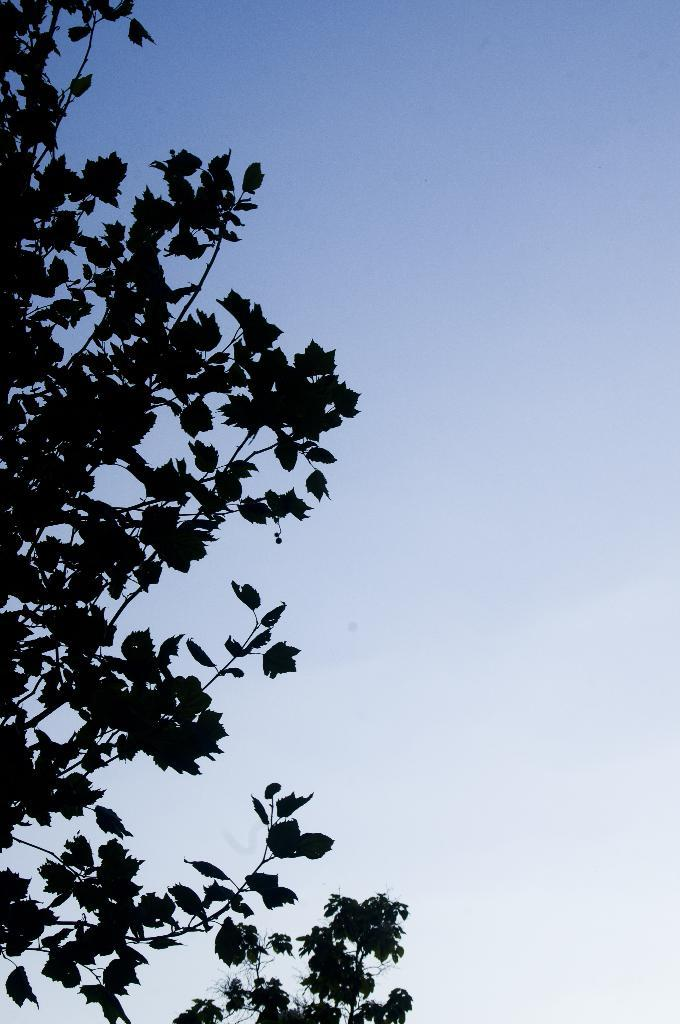What type of vegetation can be seen in the image? There are trees in the image. What part of the natural environment is visible in the image? The sky is visible in the background of the image. What type of shoes can be seen hanging from the trees in the image? There are no shoes present in the image; it only features trees and the sky. 